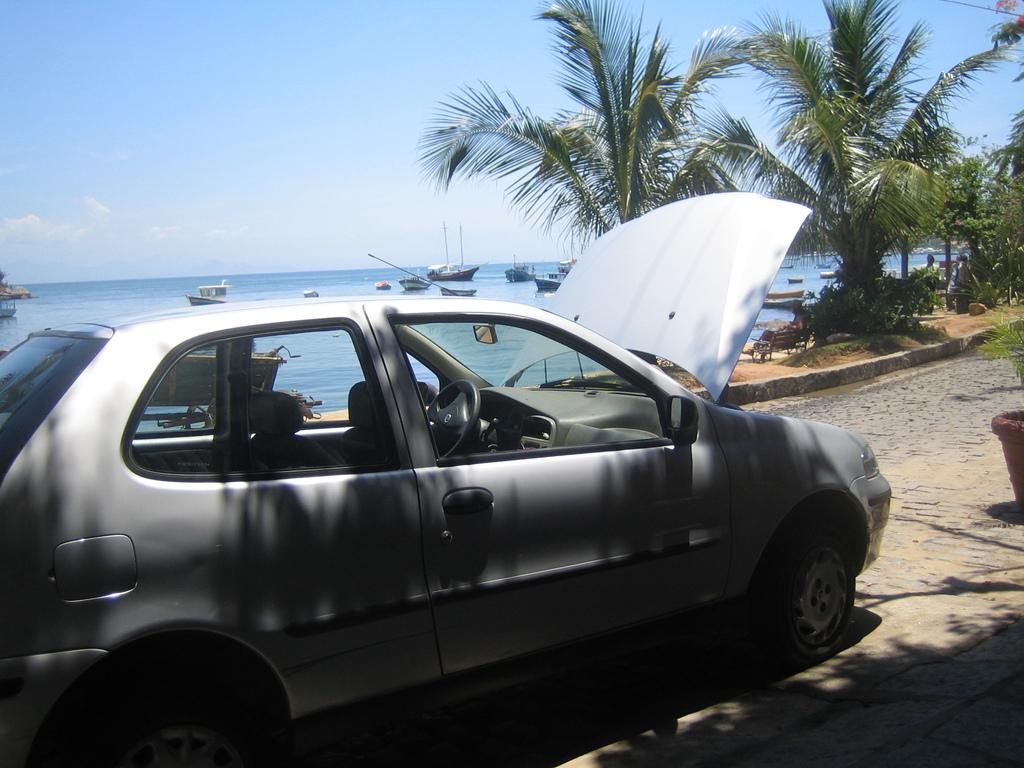What is the main subject of the image? There is a vehicle in the image. What can be seen in the background of the image? There are trees and boats on the water in the background of the image. What is the color of the trees in the image? The trees are green. How would you describe the sky in the image? The sky is blue and white. What type of quince is being sold at the street vendor in the image? There is no street vendor or quince present in the image. How many berries are visible on the trees in the image? There are no berries visible on the trees in the image; they are green. 